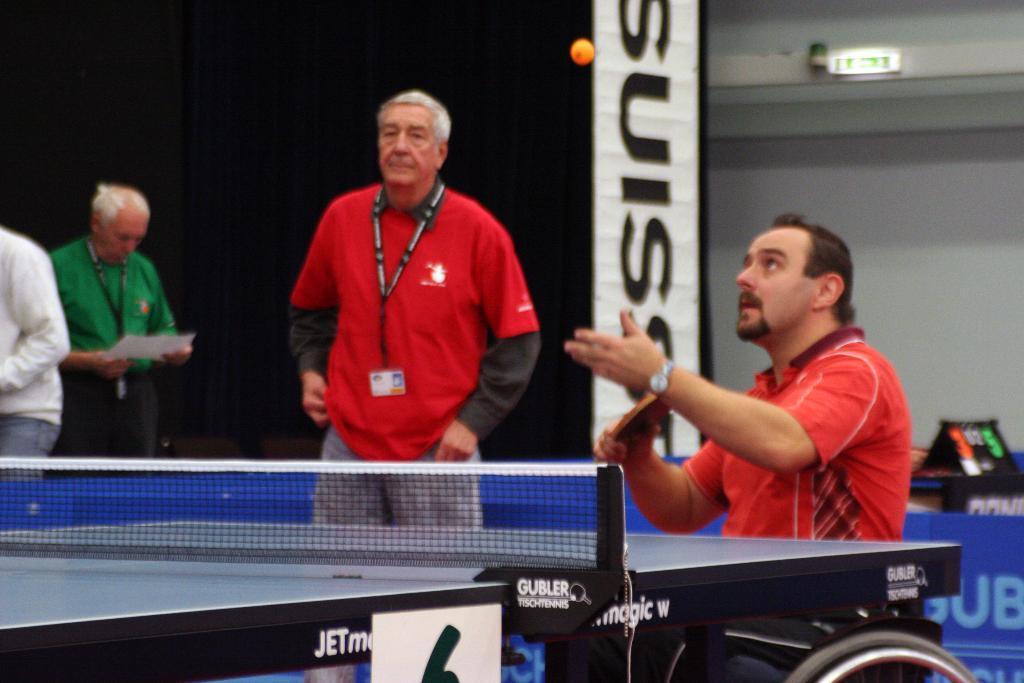Can you describe this image briefly? As we can see in the image there is a white color wall, banner and four people over here and there is a net. 